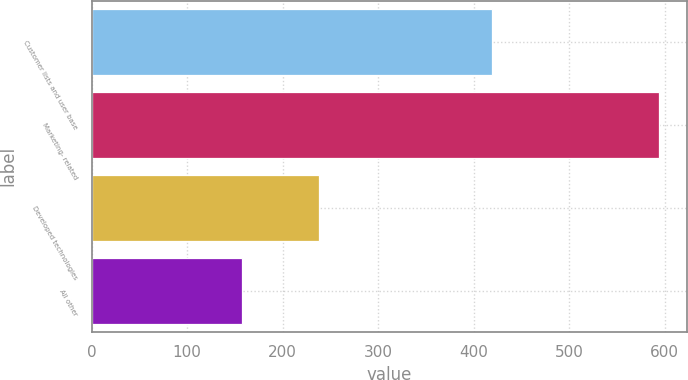<chart> <loc_0><loc_0><loc_500><loc_500><bar_chart><fcel>Customer lists and user base<fcel>Marketing- related<fcel>Developed technologies<fcel>All other<nl><fcel>419<fcel>594<fcel>238<fcel>157<nl></chart> 